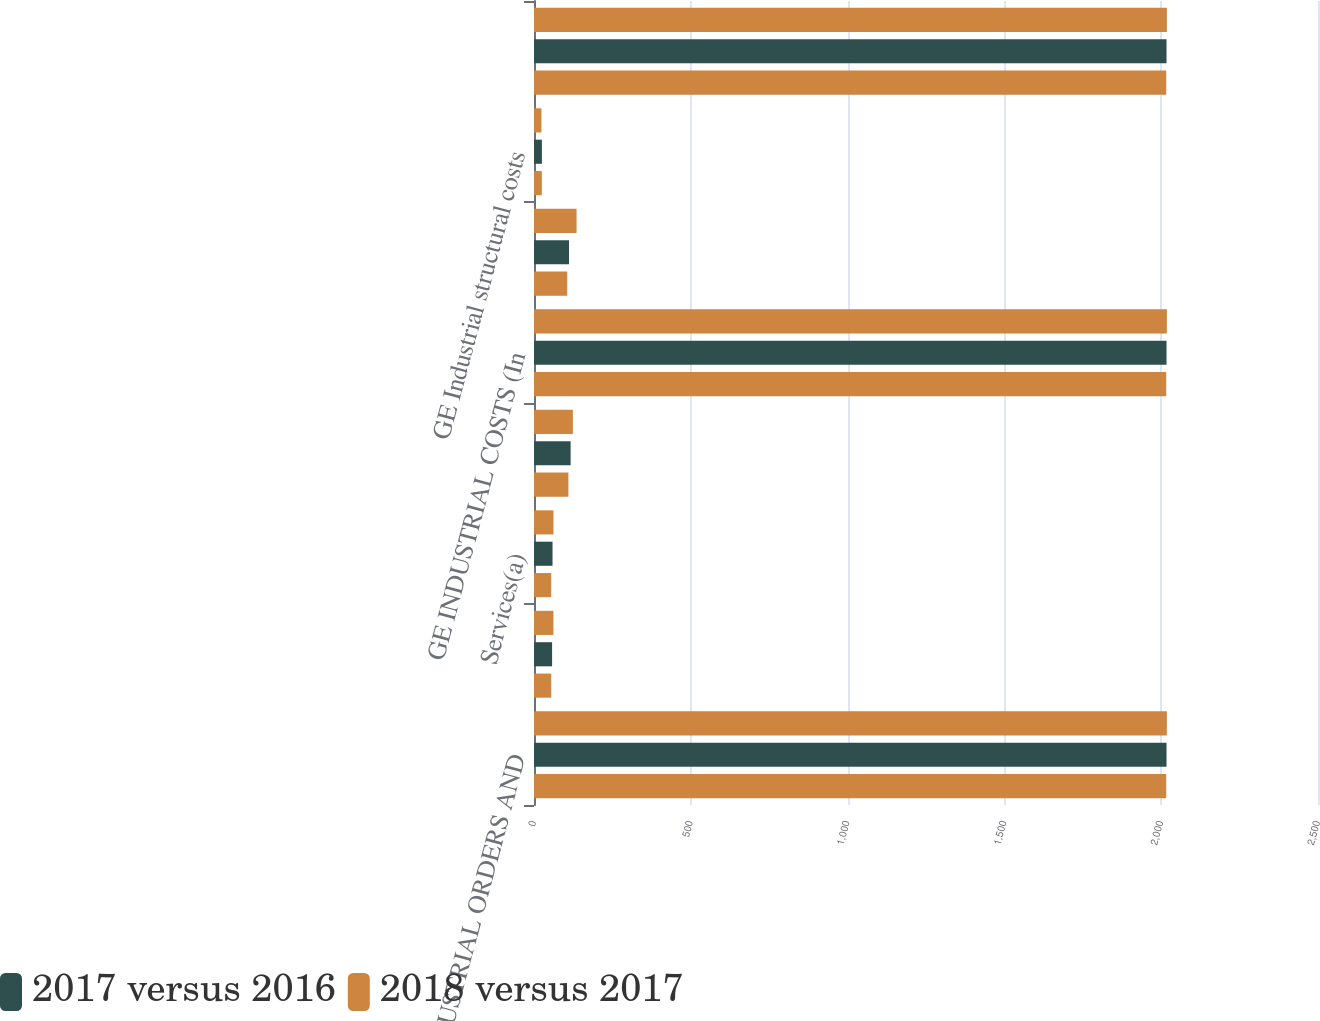Convert chart to OTSL. <chart><loc_0><loc_0><loc_500><loc_500><stacked_bar_chart><ecel><fcel>GE INDUSTRIAL ORDERS AND<fcel>Equipment<fcel>Services(a)<fcel>Total<fcel>GE INDUSTRIAL COSTS (In<fcel>GE total costs and expenses<fcel>GE Industrial structural costs<fcel>GE INDUSTRIAL PROFIT MARGIN<nl><fcel>nan<fcel>2018<fcel>61.9<fcel>62.1<fcel>124<fcel>2018<fcel>135.7<fcel>23.7<fcel>2018<nl><fcel>2017 versus 2016<fcel>2017<fcel>57.7<fcel>59.1<fcel>116.8<fcel>2017<fcel>111.7<fcel>25.2<fcel>2017<nl><fcel>2018 versus 2017<fcel>2016<fcel>54.9<fcel>54.8<fcel>109.7<fcel>2016<fcel>105.8<fcel>25<fcel>2016<nl></chart> 